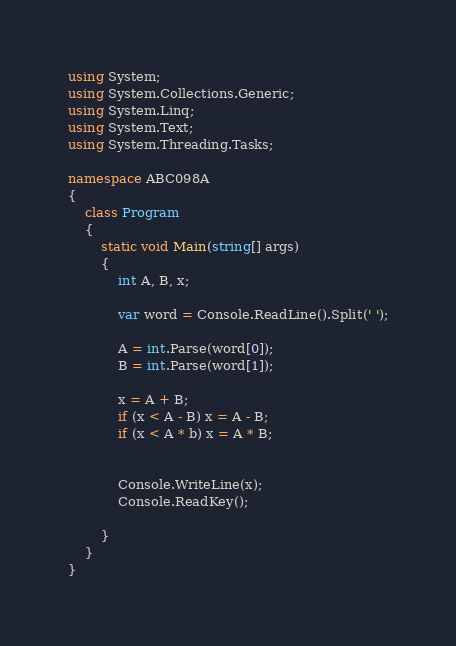Convert code to text. <code><loc_0><loc_0><loc_500><loc_500><_C#_>using System;
using System.Collections.Generic;
using System.Linq;
using System.Text;
using System.Threading.Tasks;

namespace ABC098A
{
    class Program
    {
        static void Main(string[] args)
        {
            int A, B, x;

            var word = Console.ReadLine().Split(' ');

            A = int.Parse(word[0]);
            B = int.Parse(word[1]);

            x = A + B;
            if (x < A - B) x = A - B;
            if (x < A * b) x = A * B;


            Console.WriteLine(x);
            Console.ReadKey();

        }
    }
}
</code> 